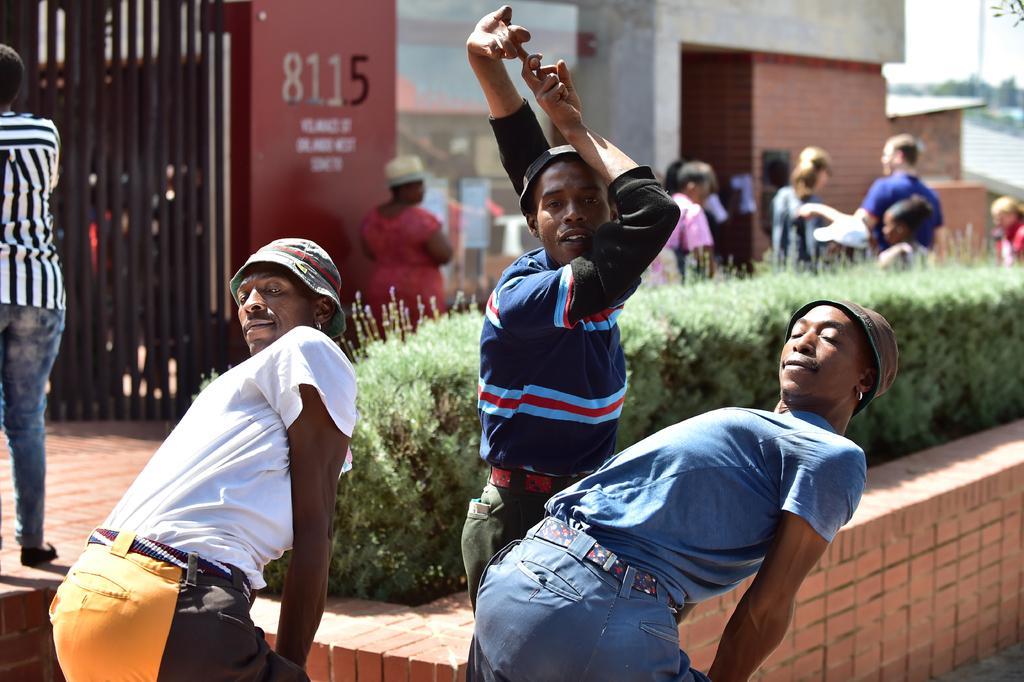How would you summarize this image in a sentence or two? In this picture I can see group of people standing, there are buildings, there are plants. At the top right corner of the image there is the sky. 